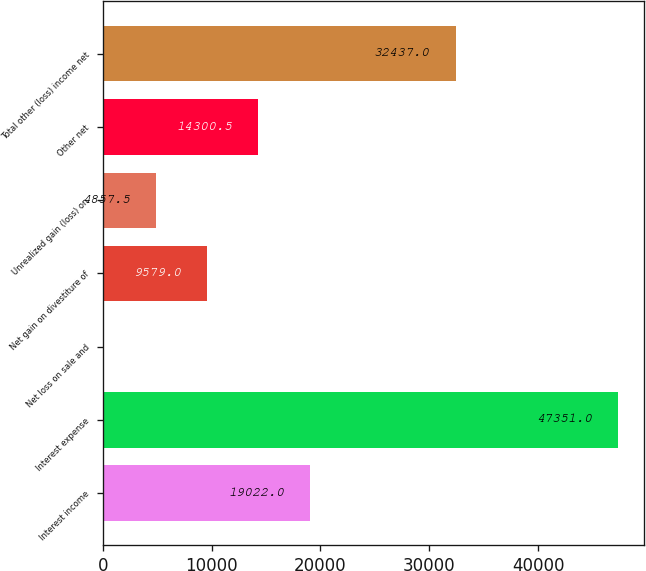Convert chart. <chart><loc_0><loc_0><loc_500><loc_500><bar_chart><fcel>Interest income<fcel>Interest expense<fcel>Net loss on sale and<fcel>Net gain on divestiture of<fcel>Unrealized gain (loss) on<fcel>Other net<fcel>Total other (loss) income net<nl><fcel>19022<fcel>47351<fcel>136<fcel>9579<fcel>4857.5<fcel>14300.5<fcel>32437<nl></chart> 